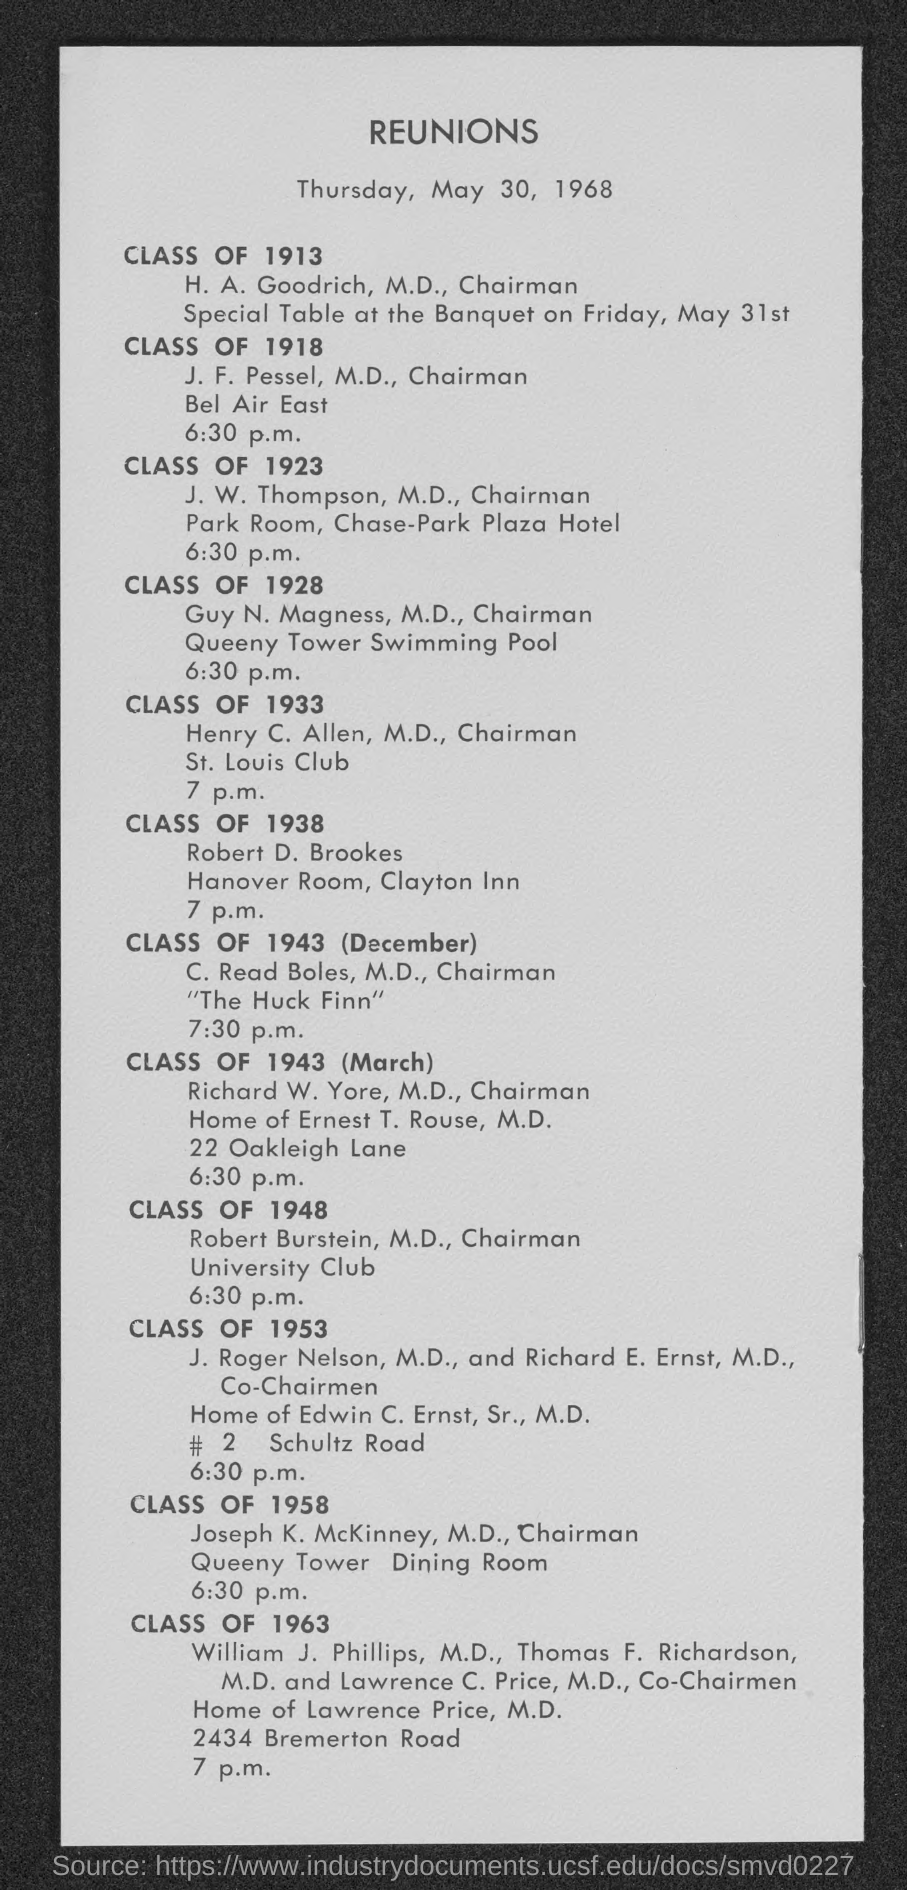List a handful of essential elements in this visual. The reunion of the Class of 1923 was scheduled to occur at 6:30 p.m. The reunion was organized on Thursday, May 30, 1968. The reunion of the Class of 1953 was scheduled to take place at 6:30 p.m. The reunion of the Class of 1958 was organized in the Queeny Tower Dining Room. The chairman for the reunion organized for the Class of 1928 is Guy N. Magness, M.D. 